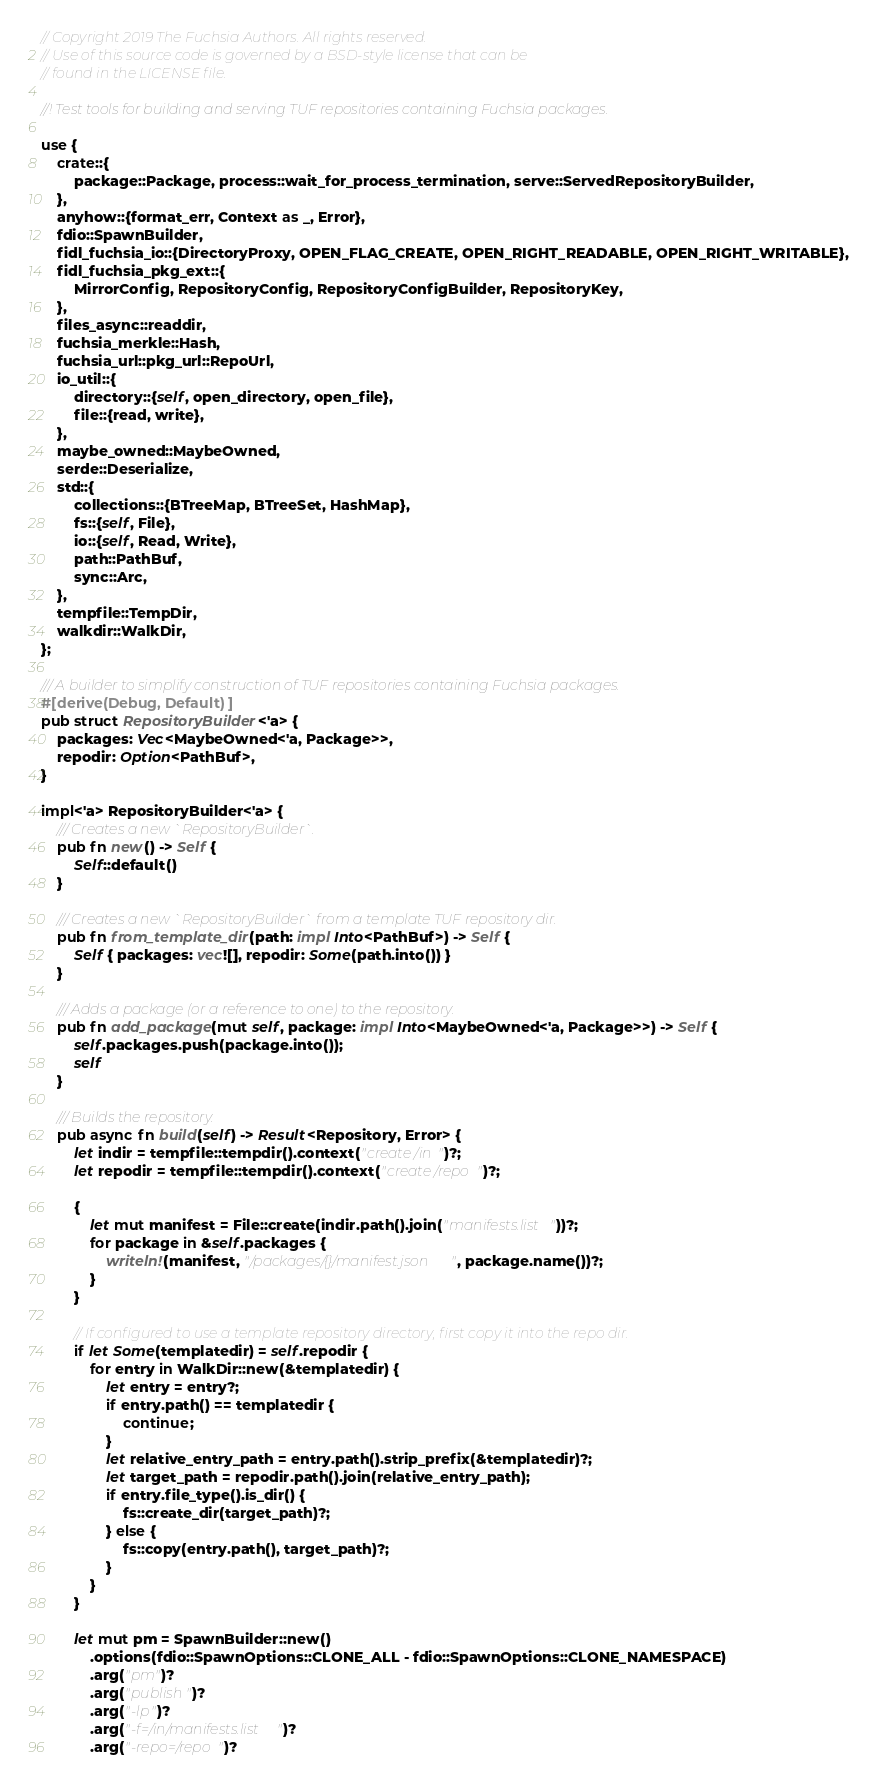Convert code to text. <code><loc_0><loc_0><loc_500><loc_500><_Rust_>// Copyright 2019 The Fuchsia Authors. All rights reserved.
// Use of this source code is governed by a BSD-style license that can be
// found in the LICENSE file.

//! Test tools for building and serving TUF repositories containing Fuchsia packages.

use {
    crate::{
        package::Package, process::wait_for_process_termination, serve::ServedRepositoryBuilder,
    },
    anyhow::{format_err, Context as _, Error},
    fdio::SpawnBuilder,
    fidl_fuchsia_io::{DirectoryProxy, OPEN_FLAG_CREATE, OPEN_RIGHT_READABLE, OPEN_RIGHT_WRITABLE},
    fidl_fuchsia_pkg_ext::{
        MirrorConfig, RepositoryConfig, RepositoryConfigBuilder, RepositoryKey,
    },
    files_async::readdir,
    fuchsia_merkle::Hash,
    fuchsia_url::pkg_url::RepoUrl,
    io_util::{
        directory::{self, open_directory, open_file},
        file::{read, write},
    },
    maybe_owned::MaybeOwned,
    serde::Deserialize,
    std::{
        collections::{BTreeMap, BTreeSet, HashMap},
        fs::{self, File},
        io::{self, Read, Write},
        path::PathBuf,
        sync::Arc,
    },
    tempfile::TempDir,
    walkdir::WalkDir,
};

/// A builder to simplify construction of TUF repositories containing Fuchsia packages.
#[derive(Debug, Default)]
pub struct RepositoryBuilder<'a> {
    packages: Vec<MaybeOwned<'a, Package>>,
    repodir: Option<PathBuf>,
}

impl<'a> RepositoryBuilder<'a> {
    /// Creates a new `RepositoryBuilder`.
    pub fn new() -> Self {
        Self::default()
    }

    /// Creates a new `RepositoryBuilder` from a template TUF repository dir.
    pub fn from_template_dir(path: impl Into<PathBuf>) -> Self {
        Self { packages: vec![], repodir: Some(path.into()) }
    }

    /// Adds a package (or a reference to one) to the repository.
    pub fn add_package(mut self, package: impl Into<MaybeOwned<'a, Package>>) -> Self {
        self.packages.push(package.into());
        self
    }

    /// Builds the repository.
    pub async fn build(self) -> Result<Repository, Error> {
        let indir = tempfile::tempdir().context("create /in")?;
        let repodir = tempfile::tempdir().context("create /repo")?;

        {
            let mut manifest = File::create(indir.path().join("manifests.list"))?;
            for package in &self.packages {
                writeln!(manifest, "/packages/{}/manifest.json", package.name())?;
            }
        }

        // If configured to use a template repository directory, first copy it into the repo dir.
        if let Some(templatedir) = self.repodir {
            for entry in WalkDir::new(&templatedir) {
                let entry = entry?;
                if entry.path() == templatedir {
                    continue;
                }
                let relative_entry_path = entry.path().strip_prefix(&templatedir)?;
                let target_path = repodir.path().join(relative_entry_path);
                if entry.file_type().is_dir() {
                    fs::create_dir(target_path)?;
                } else {
                    fs::copy(entry.path(), target_path)?;
                }
            }
        }

        let mut pm = SpawnBuilder::new()
            .options(fdio::SpawnOptions::CLONE_ALL - fdio::SpawnOptions::CLONE_NAMESPACE)
            .arg("pm")?
            .arg("publish")?
            .arg("-lp")?
            .arg("-f=/in/manifests.list")?
            .arg("-repo=/repo")?</code> 